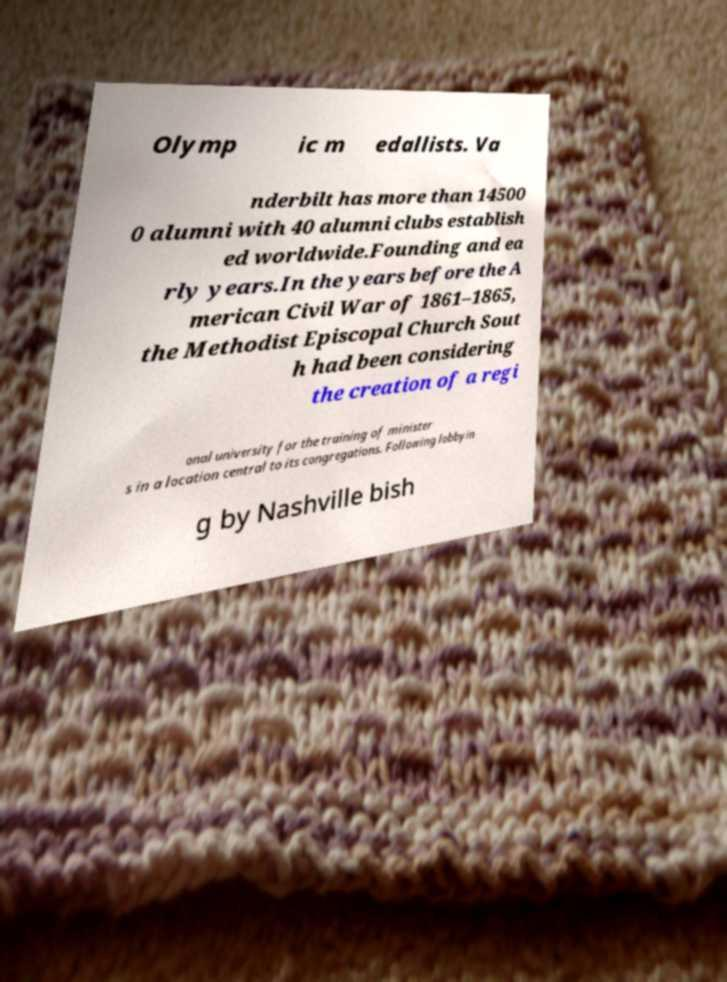Can you accurately transcribe the text from the provided image for me? Olymp ic m edallists. Va nderbilt has more than 14500 0 alumni with 40 alumni clubs establish ed worldwide.Founding and ea rly years.In the years before the A merican Civil War of 1861–1865, the Methodist Episcopal Church Sout h had been considering the creation of a regi onal university for the training of minister s in a location central to its congregations. Following lobbyin g by Nashville bish 